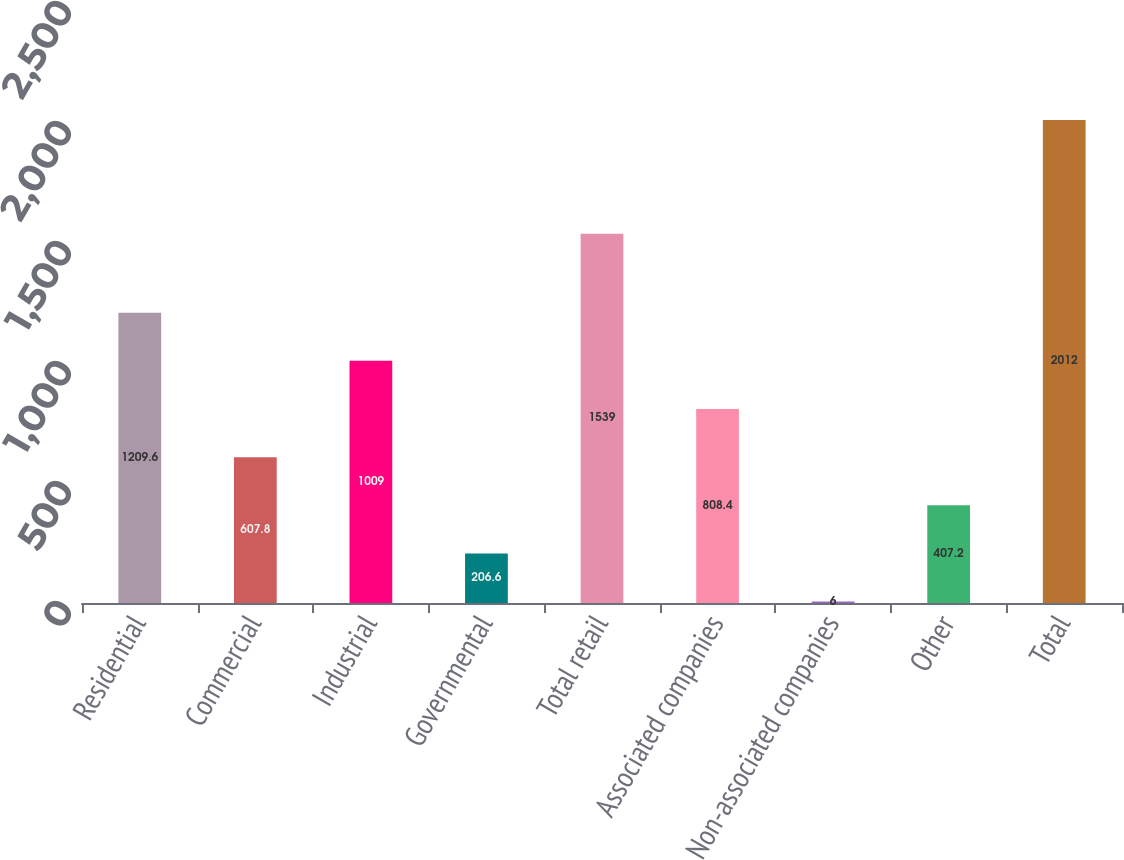<chart> <loc_0><loc_0><loc_500><loc_500><bar_chart><fcel>Residential<fcel>Commercial<fcel>Industrial<fcel>Governmental<fcel>Total retail<fcel>Associated companies<fcel>Non-associated companies<fcel>Other<fcel>Total<nl><fcel>1209.6<fcel>607.8<fcel>1009<fcel>206.6<fcel>1539<fcel>808.4<fcel>6<fcel>407.2<fcel>2012<nl></chart> 